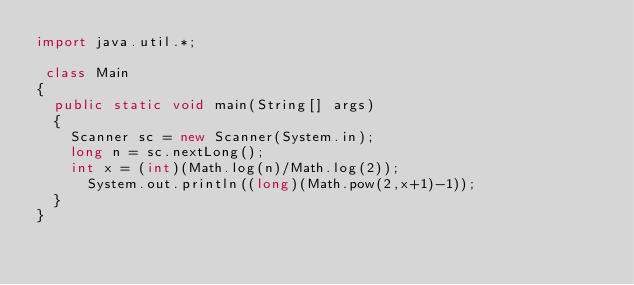<code> <loc_0><loc_0><loc_500><loc_500><_Java_>import java.util.*;
 
 class Main
{
	public static void main(String[] args)
	{
		Scanner sc = new Scanner(System.in);
		long n = sc.nextLong();
		int x = (int)(Math.log(n)/Math.log(2));
	    System.out.println((long)(Math.pow(2,x+1)-1));
	}
}</code> 